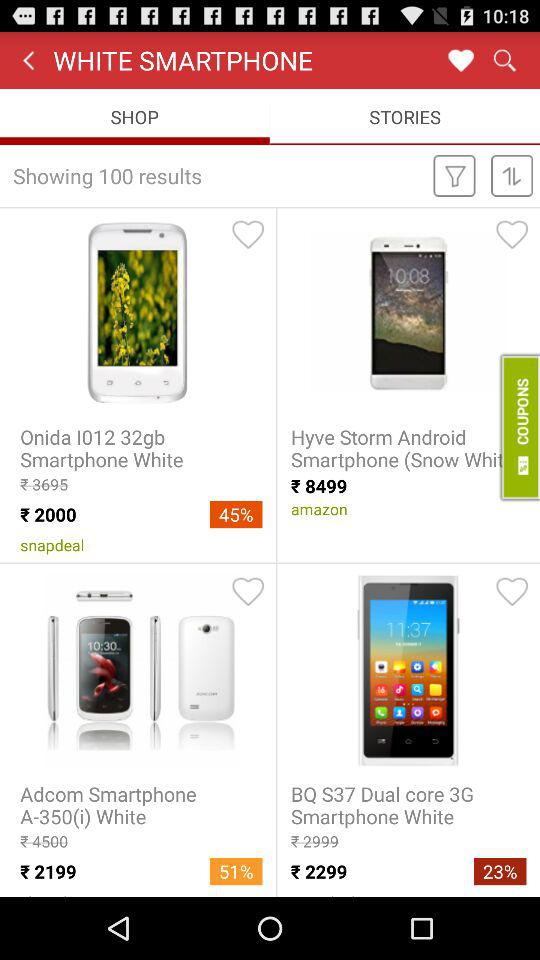On which shopping platform is "Hyve Storm" available? The shopping platform on which "Hyve Storm" is available is "amazon". 